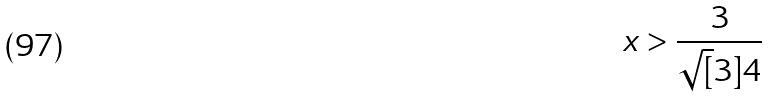<formula> <loc_0><loc_0><loc_500><loc_500>x > \frac { 3 } { \sqrt { [ } 3 ] { 4 } }</formula> 